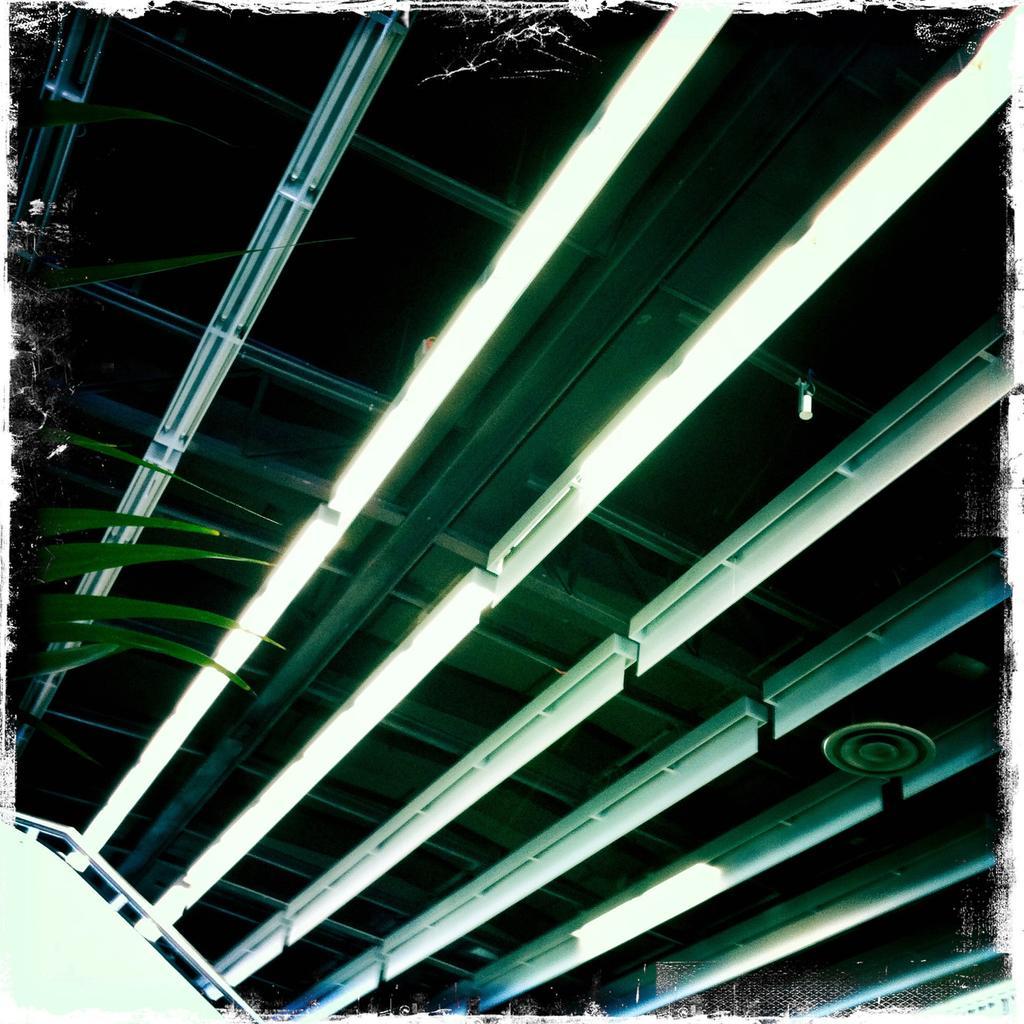Describe this image in one or two sentences. In this image, we can see a roof with few lights. On the left side, we can see a plant. 